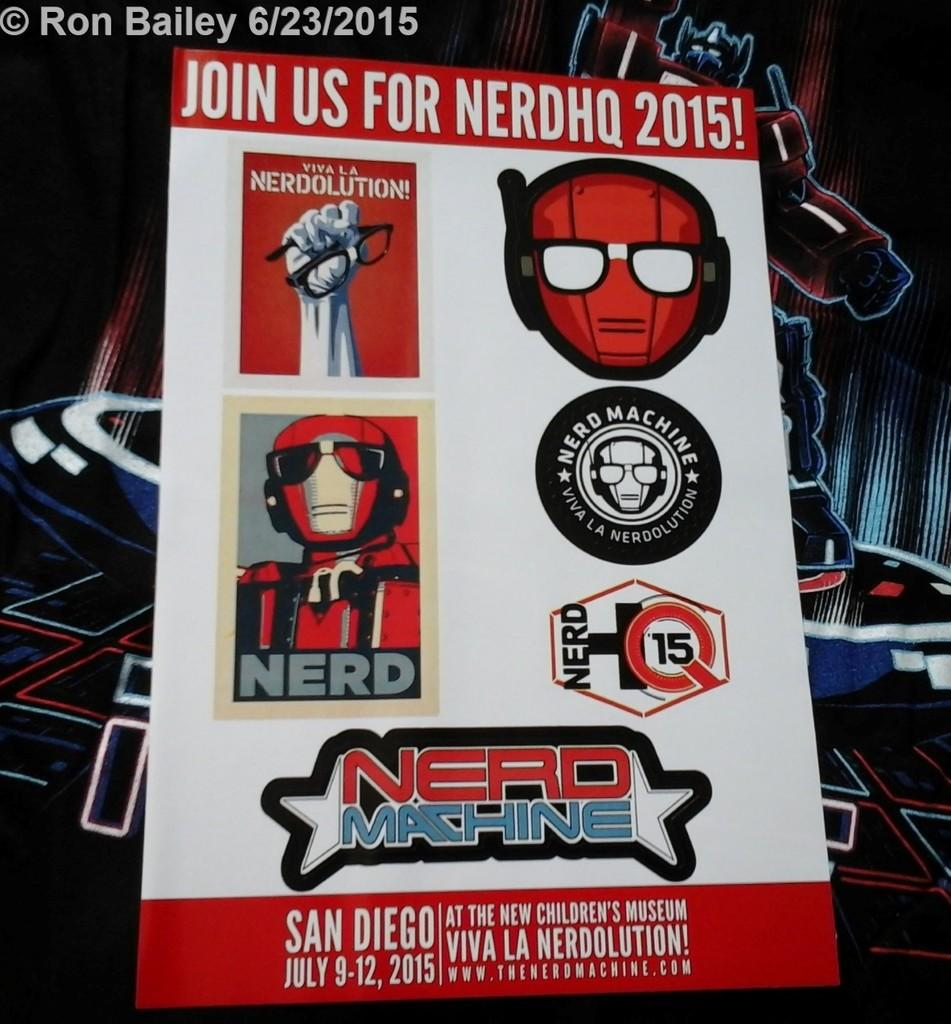<image>
Write a terse but informative summary of the picture. A poster in primarily red and white advertising something called NerdHQ 2015 